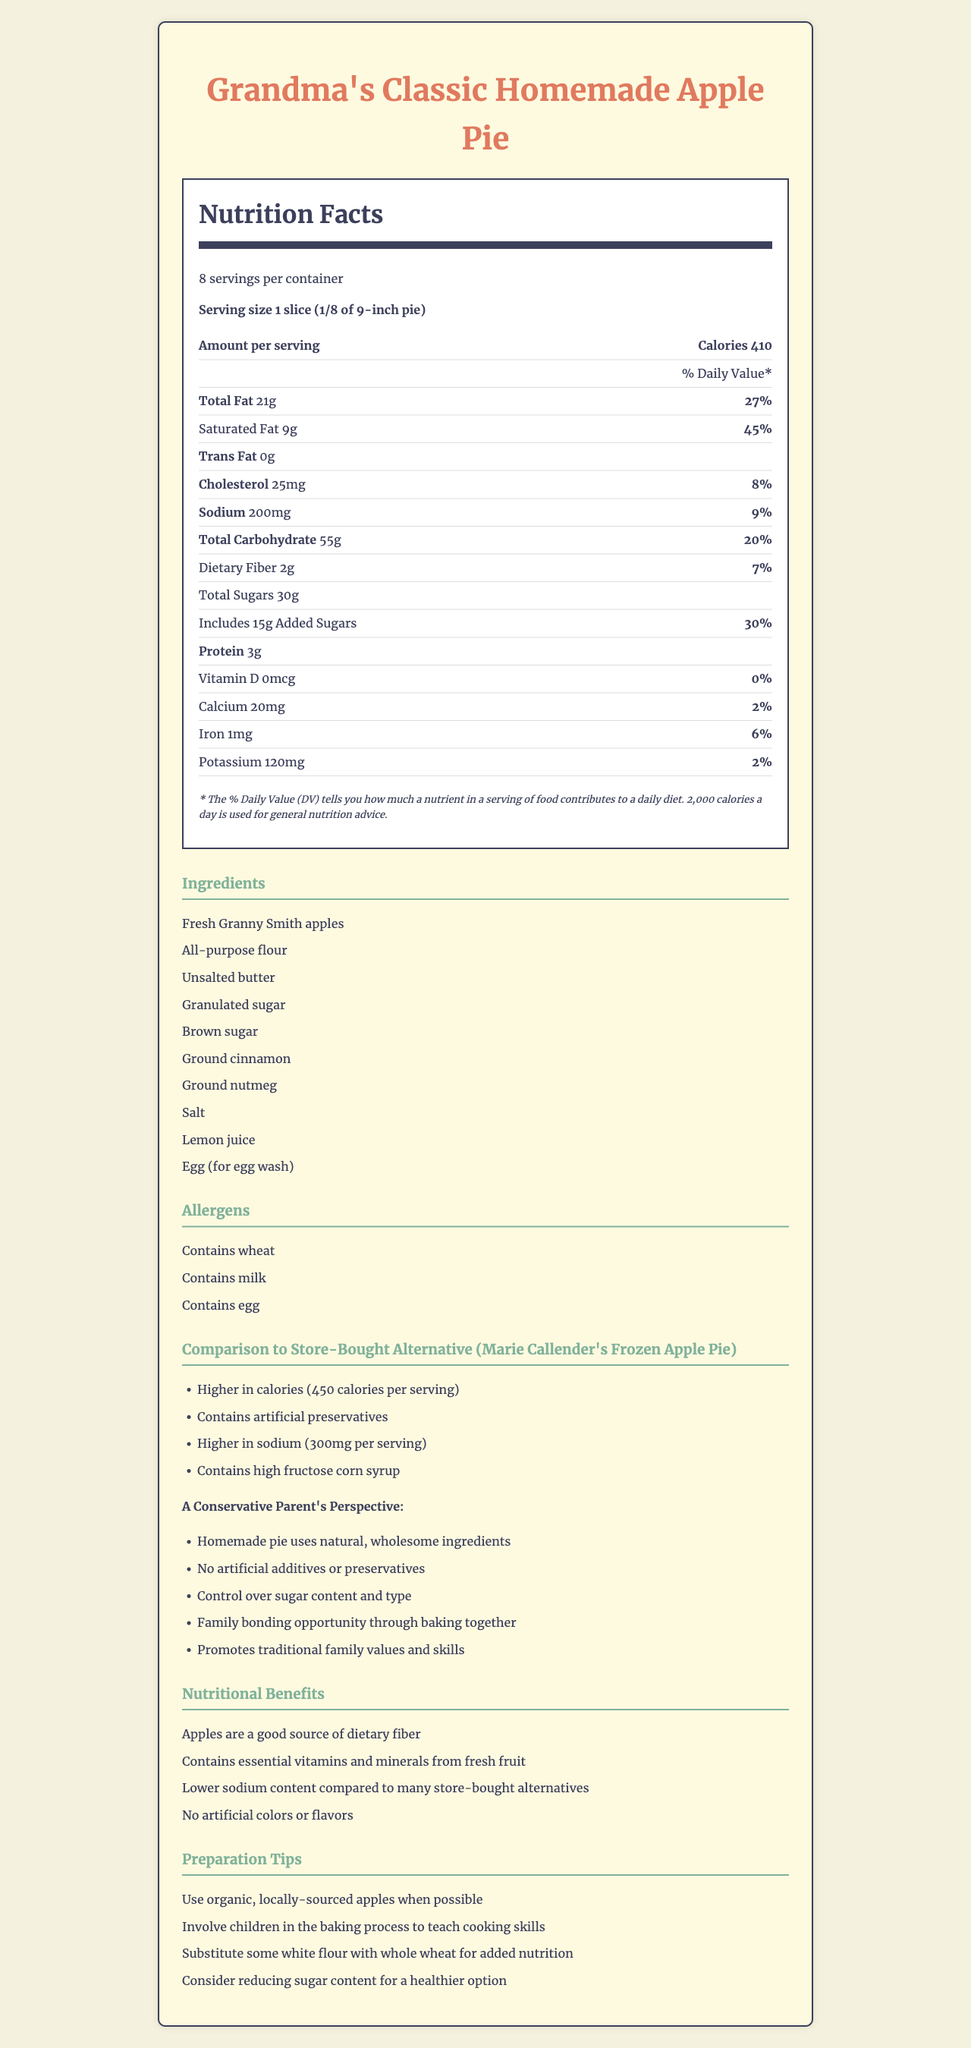who is the comparison with store-bought apple pie made with? The document explicitly mentions that the comparison is made with "Marie Callender's Frozen Apple Pie".
Answer: Marie Callender's Frozen Apple Pie how many calories are in one serving of Grandma's Classic Homemade Apple Pie? The document lists the calories per serving as 410.
Answer: 410 calories what are the declared allergens in Grandma's Classic Homemade Apple Pie? The allergens listed in the document are wheat, milk, and egg.
Answer: Contains wheat, Contains milk, Contains egg how much sodium does one slice of Grandma's Classic Homemade Apple Pie contain? It is mentioned in the document that one slice contains 200 mg of sodium.
Answer: 200 mg how many grams of protein are in a serving of Grandma's Classic Homemade Apple Pie? The document states that one serving has 3 grams of protein.
Answer: 3 grams which of the following is NOT a preparation tip mentioned in the document? A. Use organic, locally-sourced apples B. Involve children in the baking process C. Substitute some white flour with almond flour D. Consider reducing sugar content The document mentions using whole wheat flour but not almond flour as a substitution.
Answer: C which of the following ingredients is used in Grandma's Classic Homemade Apple Pie? A. Fresh Granny Smith apples B. Artificial sweeteners C. High fructose corn syrup D. Preservatives The ingredients listed include Fresh Granny Smith apples, but none of the other options.
Answer: A does Grandma's Classic Homemade Apple Pie contain artificial additives or preservatives? The document states there are no artificial additives or preservatives in the homemade pie.
Answer: No summarize the main idea of the document. The document gives a comprehensive overview of the homemade pie's nutritional facts while comparing it with a store-bought version, emphasizing the homemade pie's natural and wholesome qualities.
Answer: The document provides nutritional information on Grandma's Classic Homemade Apple Pie, including detailed comparisons to a store-bought alternative (Marie Callender's Frozen Apple Pie). It emphasizes the benefits and wholesome ingredients of the homemade pie, listing nutritional benefits, preparation tips, and allergens. what is the total fat content per serving in Grandma's Classic Homemade Apple Pie? The document lists the total fat content per serving as 21 grams.
Answer: 21 grams how much added sugar is in one serving of Grandma's Classic Homemade Apple Pie? The document states that there are 15 grams of added sugar per serving.
Answer: 15 grams can we determine the exact amount of vitamin A in the homemade apple pie from this document? The document does not provide information on the vitamin A content in Grandma's Classic Homemade Apple Pie.
Answer: Cannot be determined 